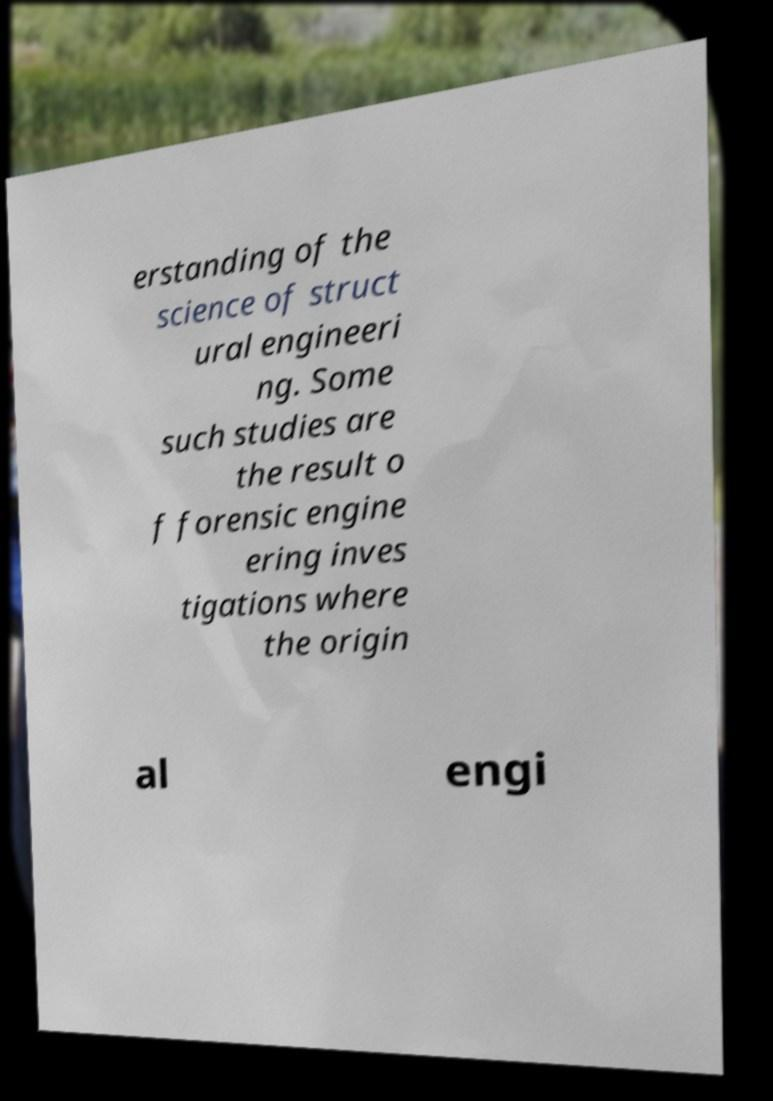Could you extract and type out the text from this image? erstanding of the science of struct ural engineeri ng. Some such studies are the result o f forensic engine ering inves tigations where the origin al engi 